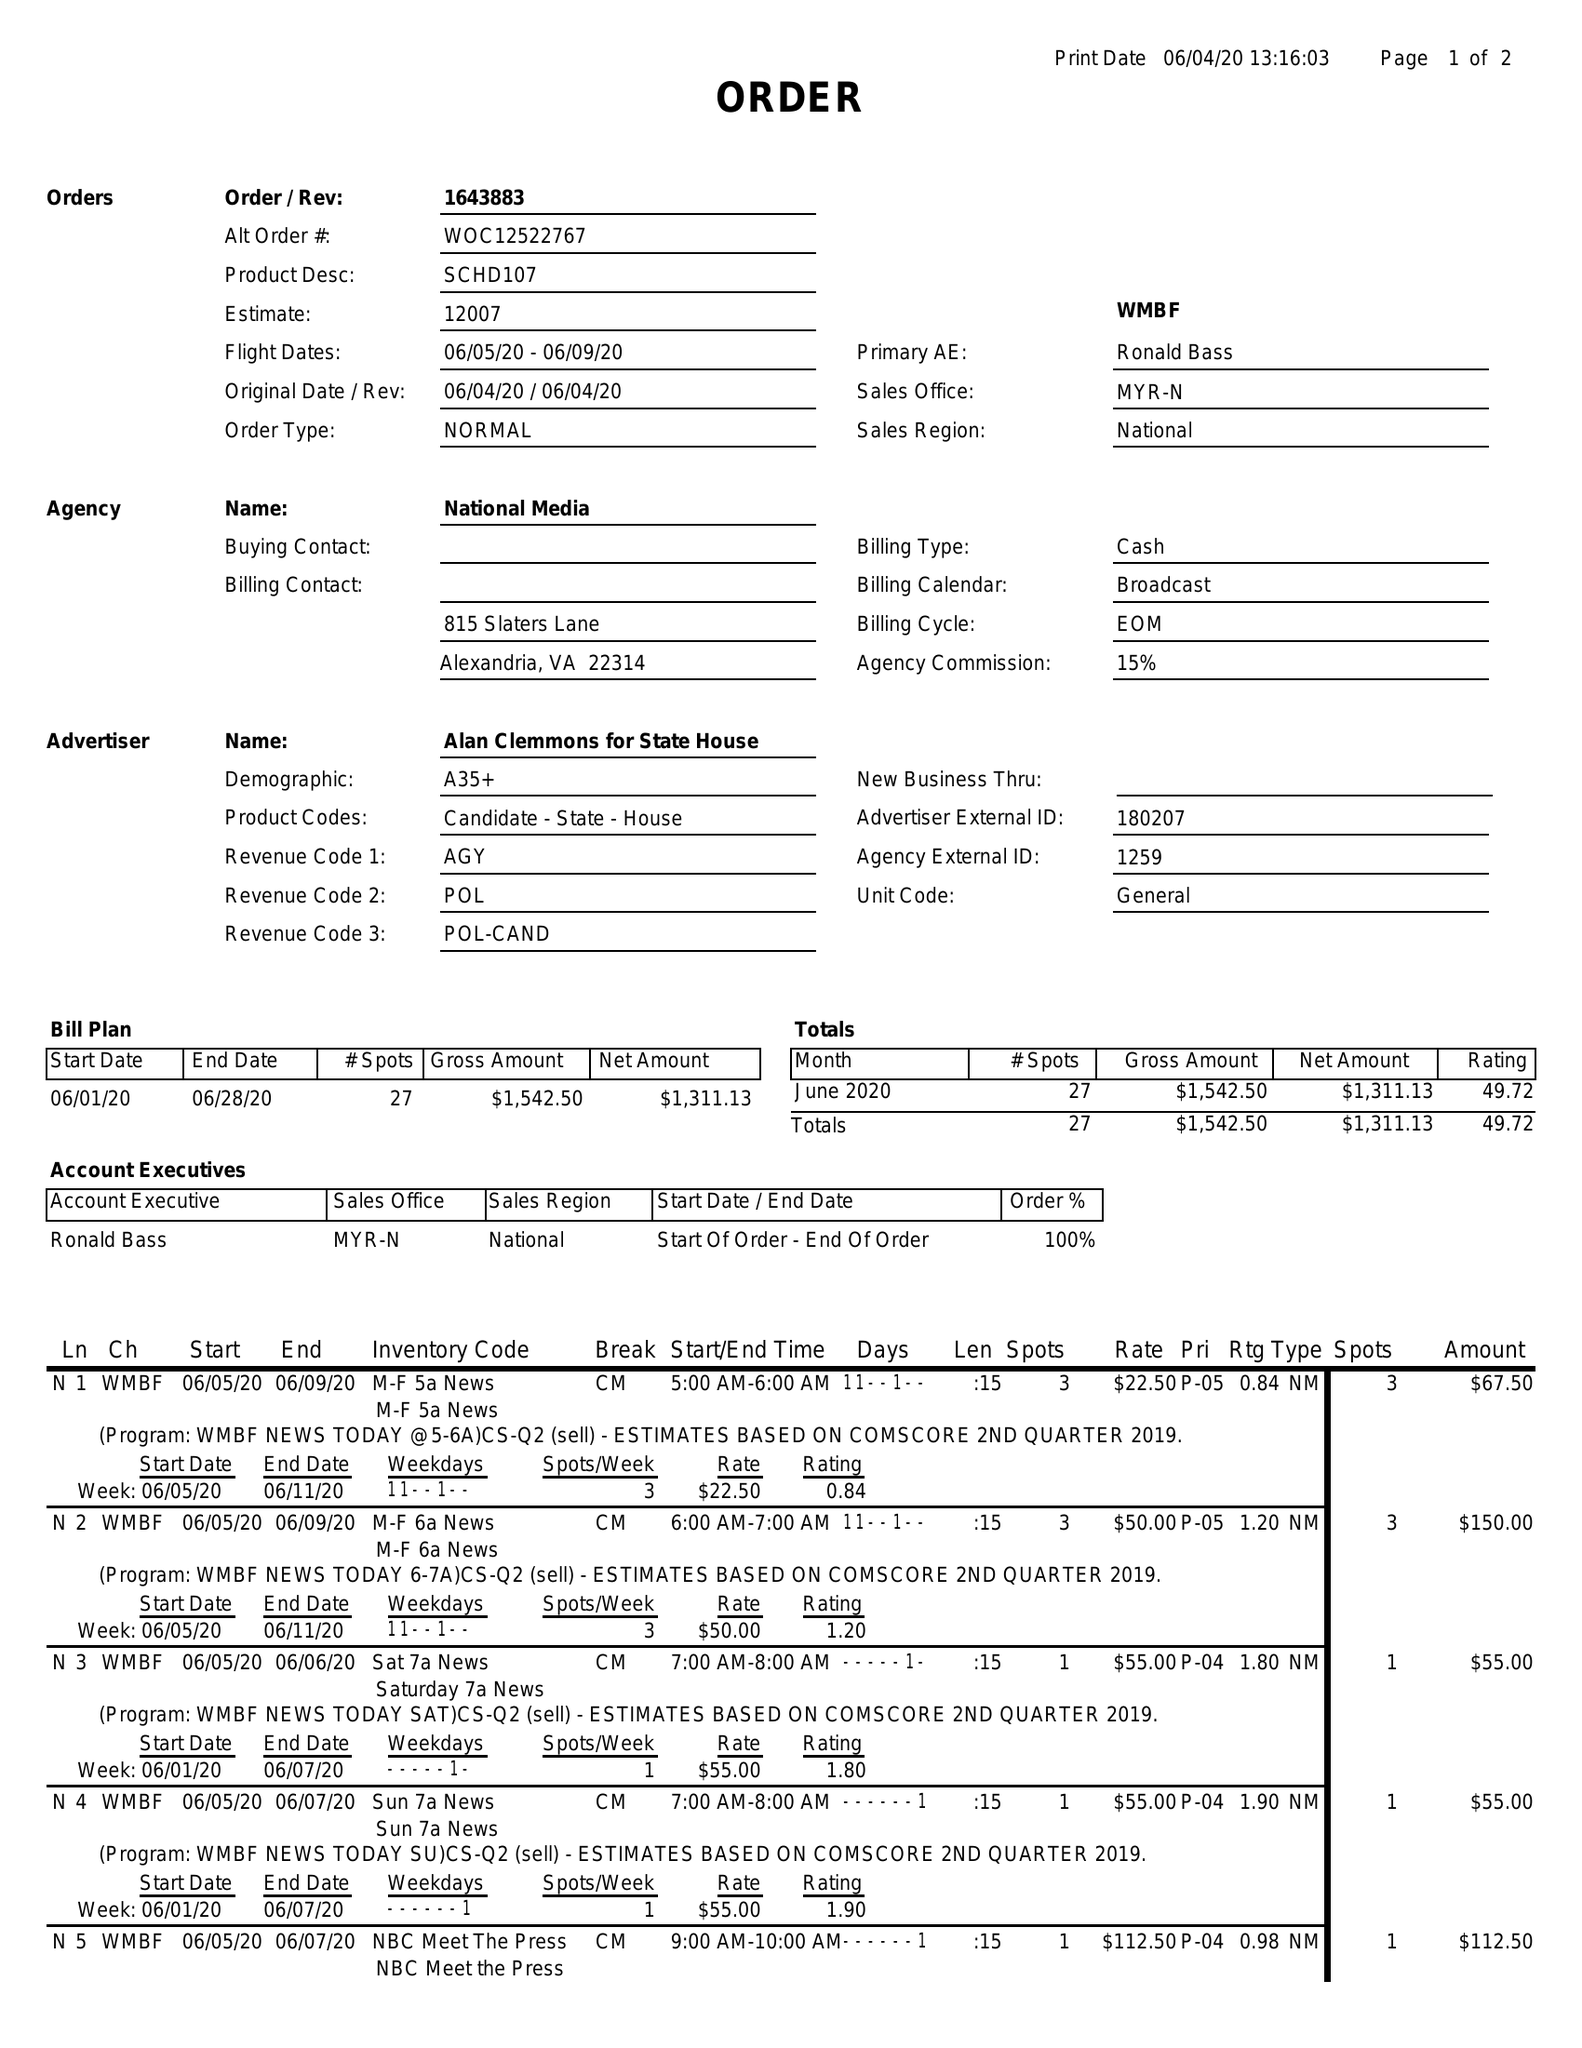What is the value for the contract_num?
Answer the question using a single word or phrase. 1643883 